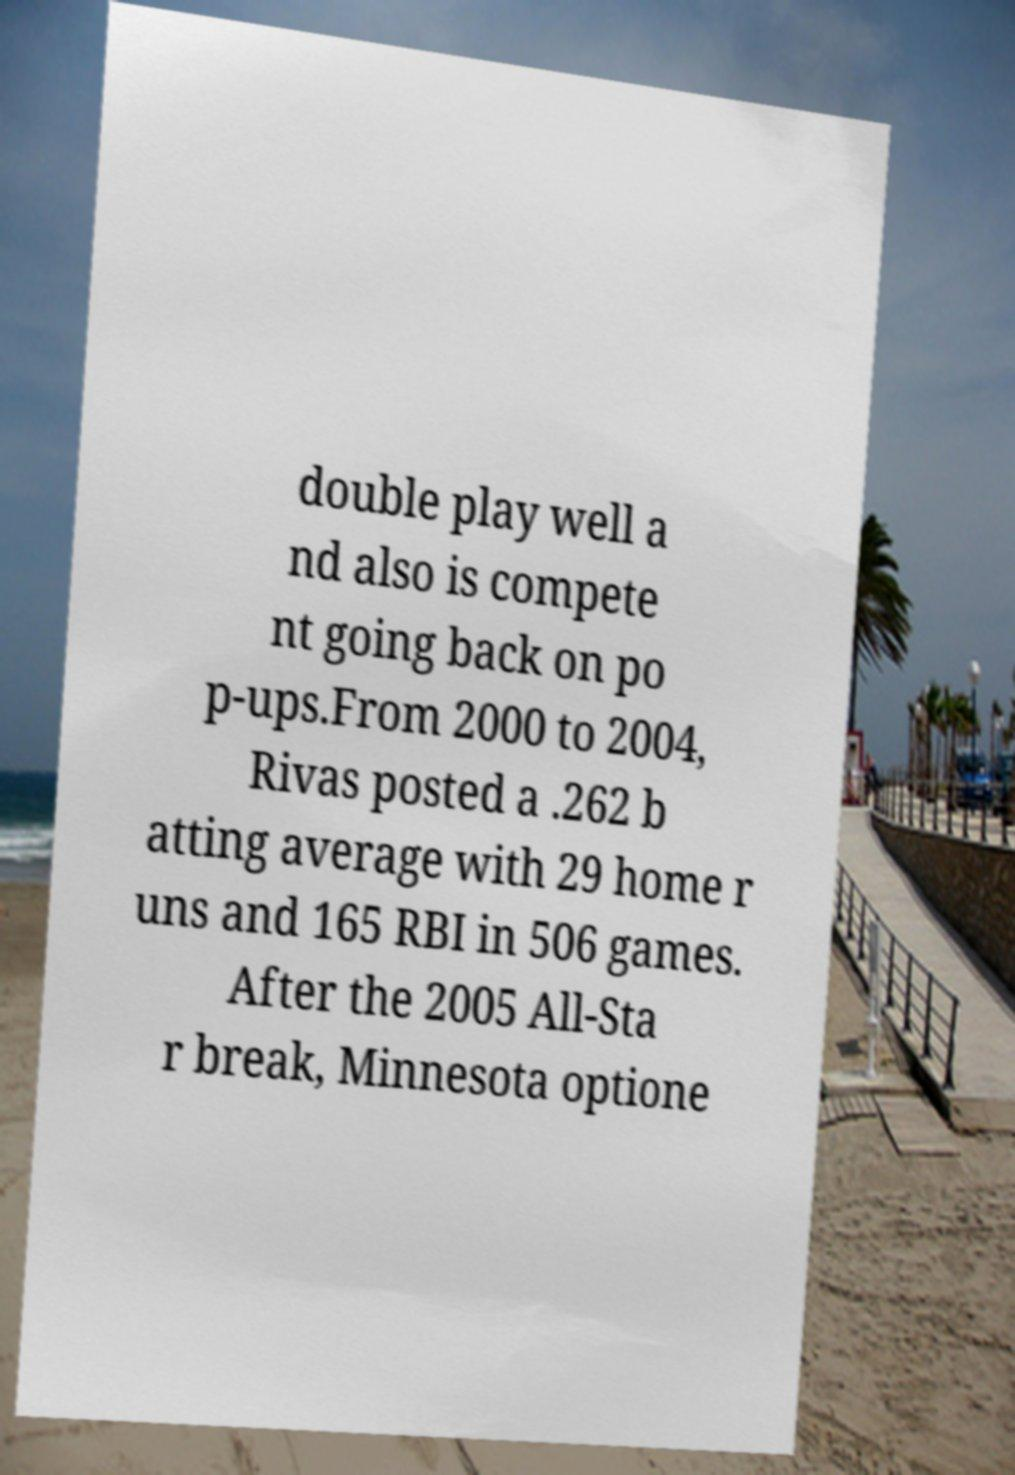Could you assist in decoding the text presented in this image and type it out clearly? double play well a nd also is compete nt going back on po p-ups.From 2000 to 2004, Rivas posted a .262 b atting average with 29 home r uns and 165 RBI in 506 games. After the 2005 All-Sta r break, Minnesota optione 